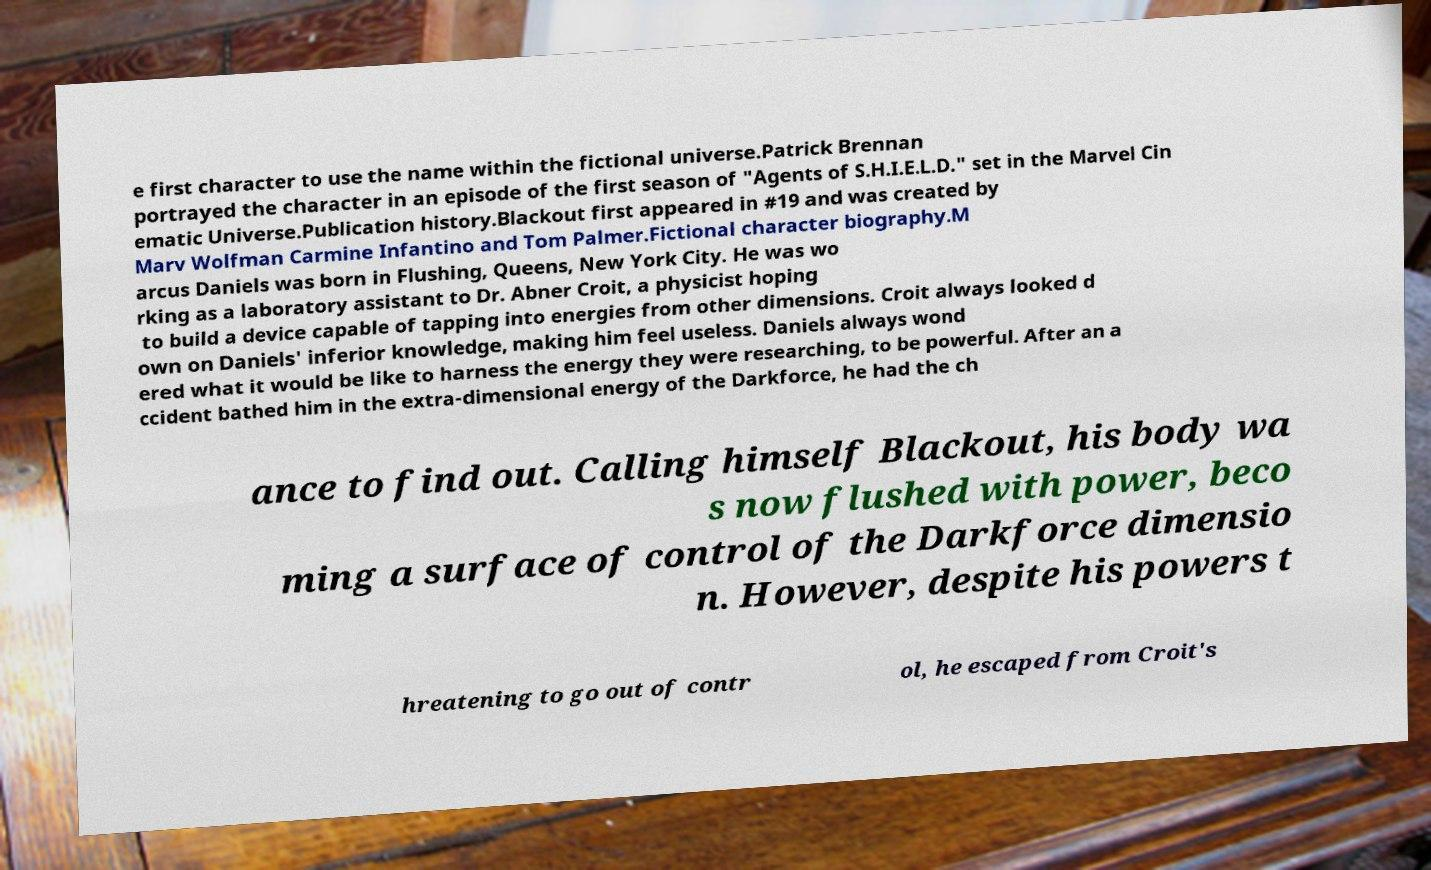What messages or text are displayed in this image? I need them in a readable, typed format. e first character to use the name within the fictional universe.Patrick Brennan portrayed the character in an episode of the first season of "Agents of S.H.I.E.L.D." set in the Marvel Cin ematic Universe.Publication history.Blackout first appeared in #19 and was created by Marv Wolfman Carmine Infantino and Tom Palmer.Fictional character biography.M arcus Daniels was born in Flushing, Queens, New York City. He was wo rking as a laboratory assistant to Dr. Abner Croit, a physicist hoping to build a device capable of tapping into energies from other dimensions. Croit always looked d own on Daniels' inferior knowledge, making him feel useless. Daniels always wond ered what it would be like to harness the energy they were researching, to be powerful. After an a ccident bathed him in the extra-dimensional energy of the Darkforce, he had the ch ance to find out. Calling himself Blackout, his body wa s now flushed with power, beco ming a surface of control of the Darkforce dimensio n. However, despite his powers t hreatening to go out of contr ol, he escaped from Croit's 